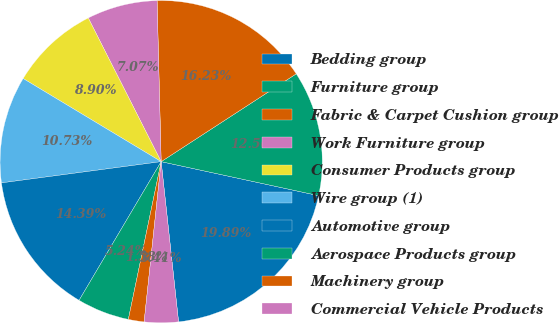<chart> <loc_0><loc_0><loc_500><loc_500><pie_chart><fcel>Bedding group<fcel>Furniture group<fcel>Fabric & Carpet Cushion group<fcel>Work Furniture group<fcel>Consumer Products group<fcel>Wire group (1)<fcel>Automotive group<fcel>Aerospace Products group<fcel>Machinery group<fcel>Commercial Vehicle Products<nl><fcel>19.89%<fcel>12.56%<fcel>16.23%<fcel>7.07%<fcel>8.9%<fcel>10.73%<fcel>14.39%<fcel>5.24%<fcel>1.58%<fcel>3.41%<nl></chart> 